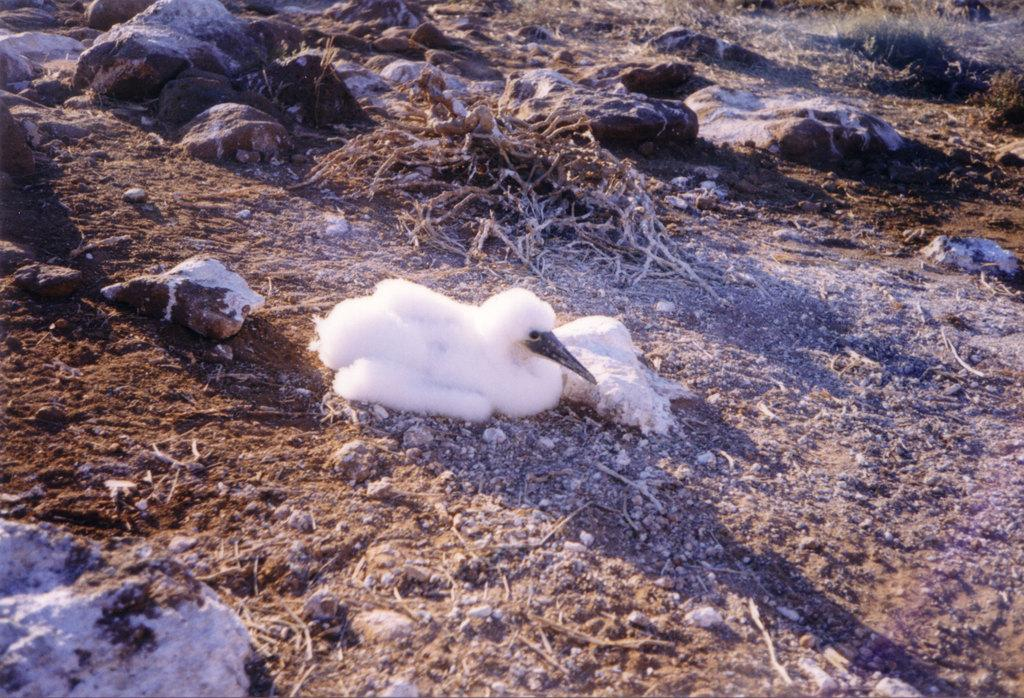What is the main subject of the image? There is a bird at the center of the image. What can be seen at the bottom of the image? There are rocks, sand, and dried grass at the bottom of the image. What type of protest is the bird leading in the image? There is no protest present in the image; it features a bird and various elements at the bottom. 